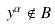<formula> <loc_0><loc_0><loc_500><loc_500>y ^ { \alpha } \notin B</formula> 